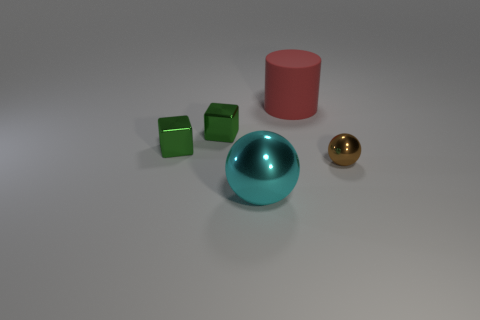There is a thing that is both to the right of the large metal thing and in front of the red thing; what is its shape? sphere 